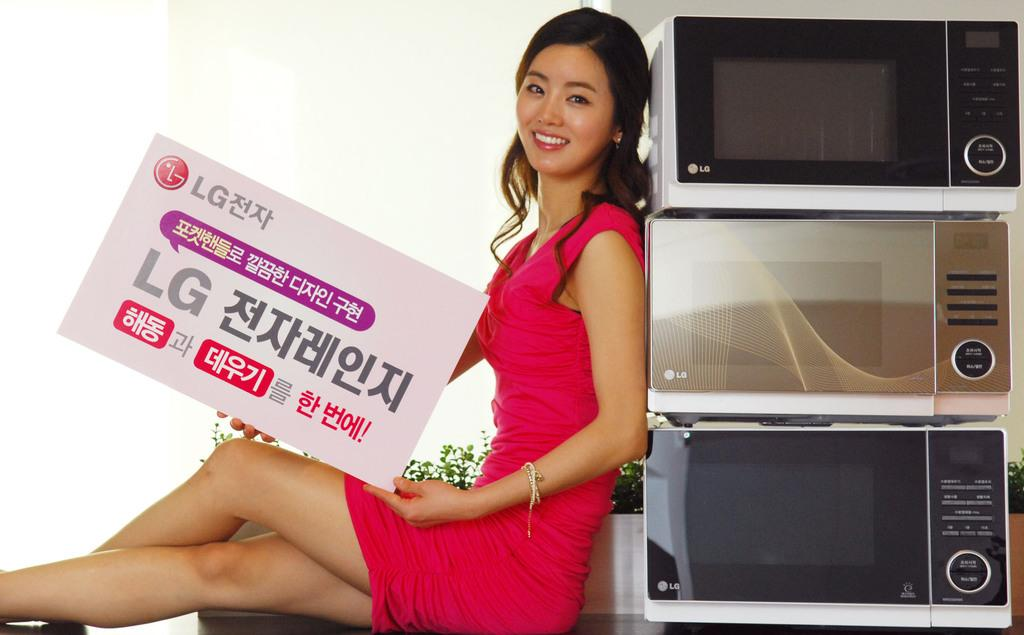<image>
Offer a succinct explanation of the picture presented. A female leaning against three stacked microwaves from LG. 